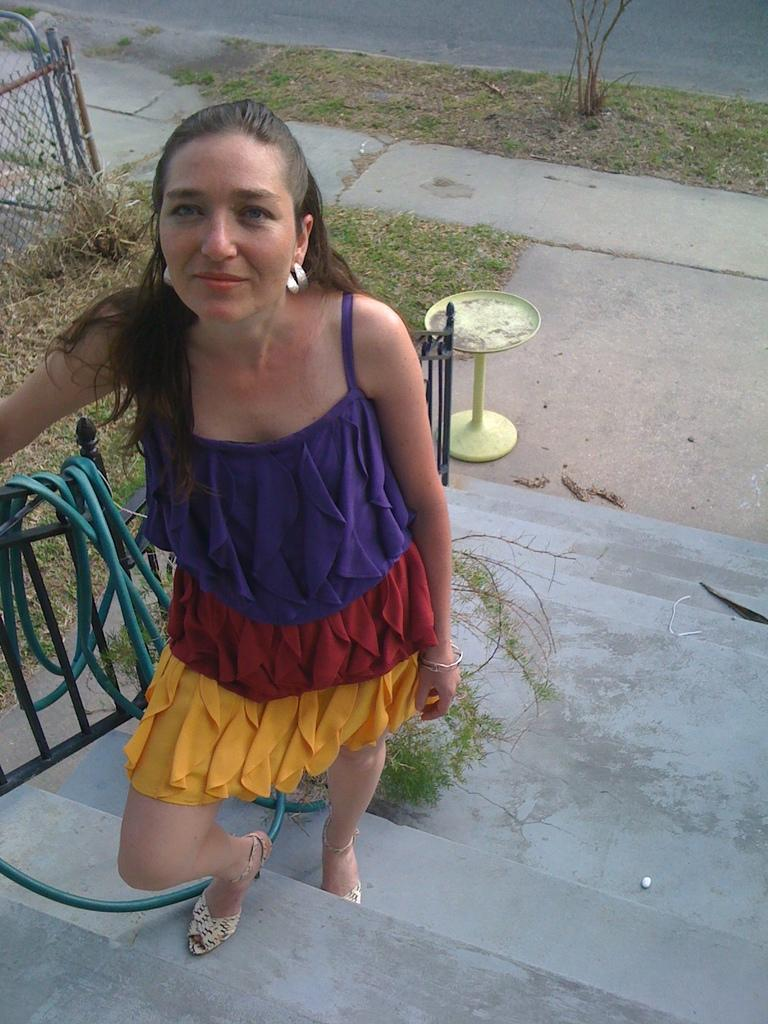What is the woman in the image doing? The woman is standing on the stairs in the image. What can be seen in the image besides the woman? There is a pipe, plants, grass, a fence, a table, and a road visible in the image. What type of vegetation is present in the image? Plants and grass are present in the image. What architectural feature can be seen in the image? There is a fence in the image. What type of surface is visible in the image? There is a road visible in the image. How many cats are sitting on the tub in the image? There is no tub or cats present in the image. What type of trail can be seen in the image? There is no trail visible in the image. 